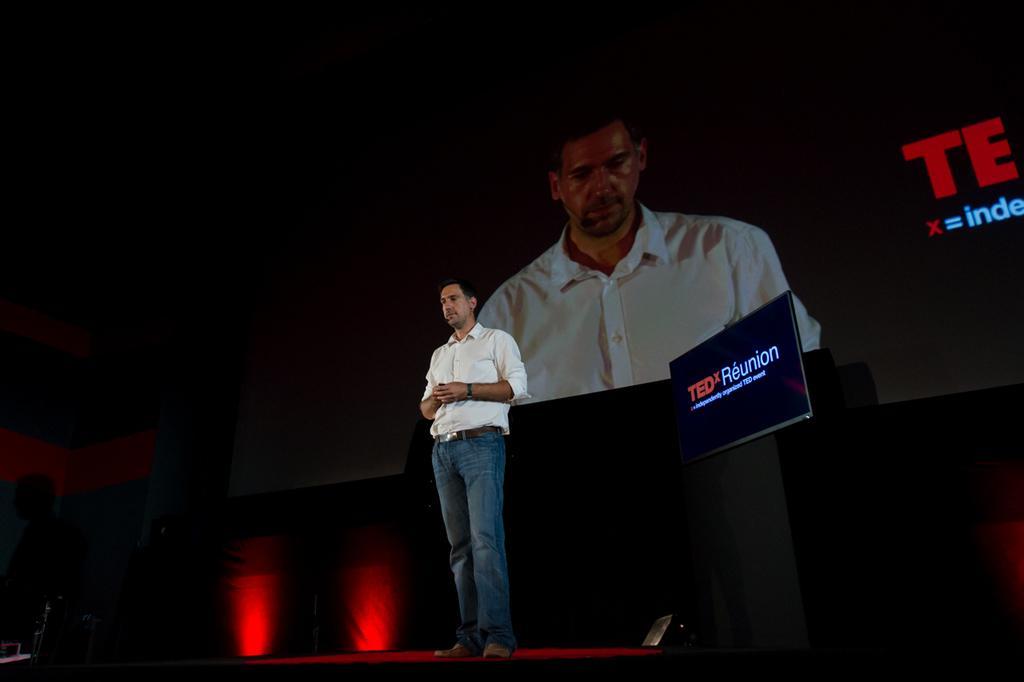In one or two sentences, can you explain what this image depicts? In this image we can see a person standing on the stage. On the backside we can see that person on the projector. We can also see a stand and a light on the floor. 